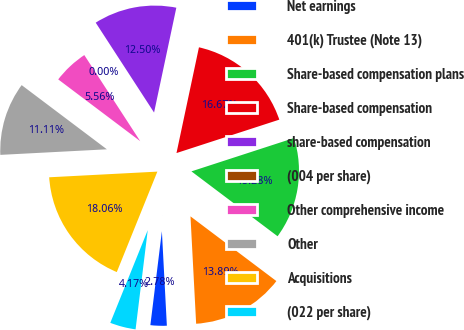Convert chart. <chart><loc_0><loc_0><loc_500><loc_500><pie_chart><fcel>Net earnings<fcel>401(k) Trustee (Note 13)<fcel>Share-based compensation plans<fcel>Share-based compensation<fcel>share-based compensation<fcel>(004 per share)<fcel>Other comprehensive income<fcel>Other<fcel>Acquisitions<fcel>(022 per share)<nl><fcel>2.78%<fcel>13.89%<fcel>15.28%<fcel>16.67%<fcel>12.5%<fcel>0.0%<fcel>5.56%<fcel>11.11%<fcel>18.06%<fcel>4.17%<nl></chart> 